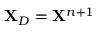<formula> <loc_0><loc_0><loc_500><loc_500>X _ { D } = X ^ { n + 1 }</formula> 